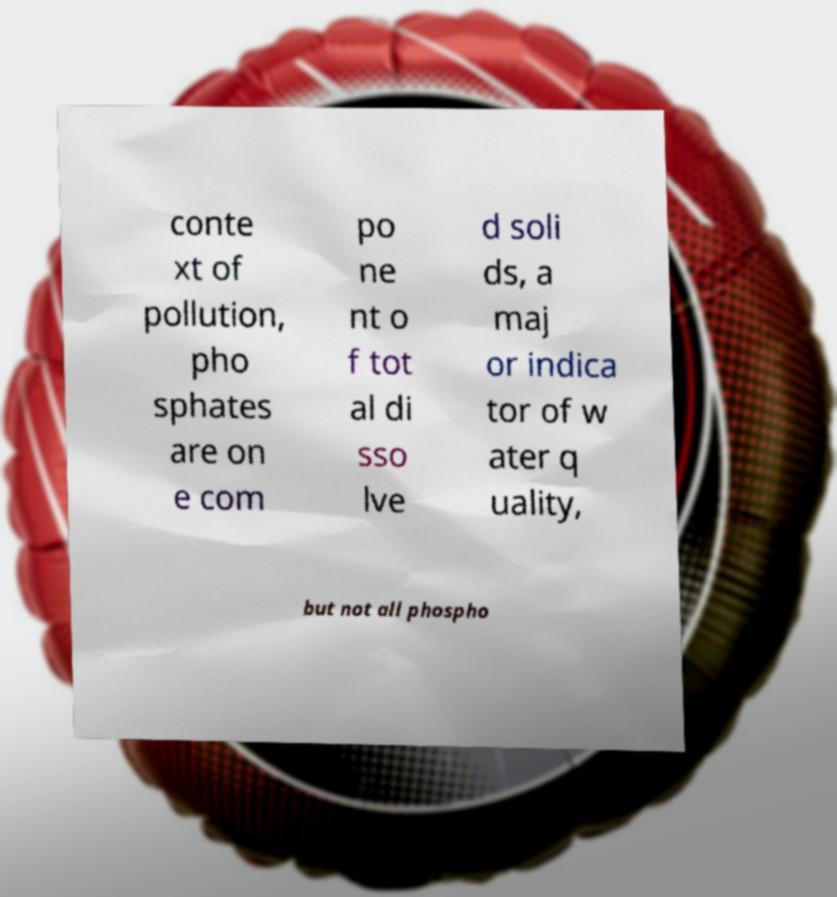What messages or text are displayed in this image? I need them in a readable, typed format. conte xt of pollution, pho sphates are on e com po ne nt o f tot al di sso lve d soli ds, a maj or indica tor of w ater q uality, but not all phospho 